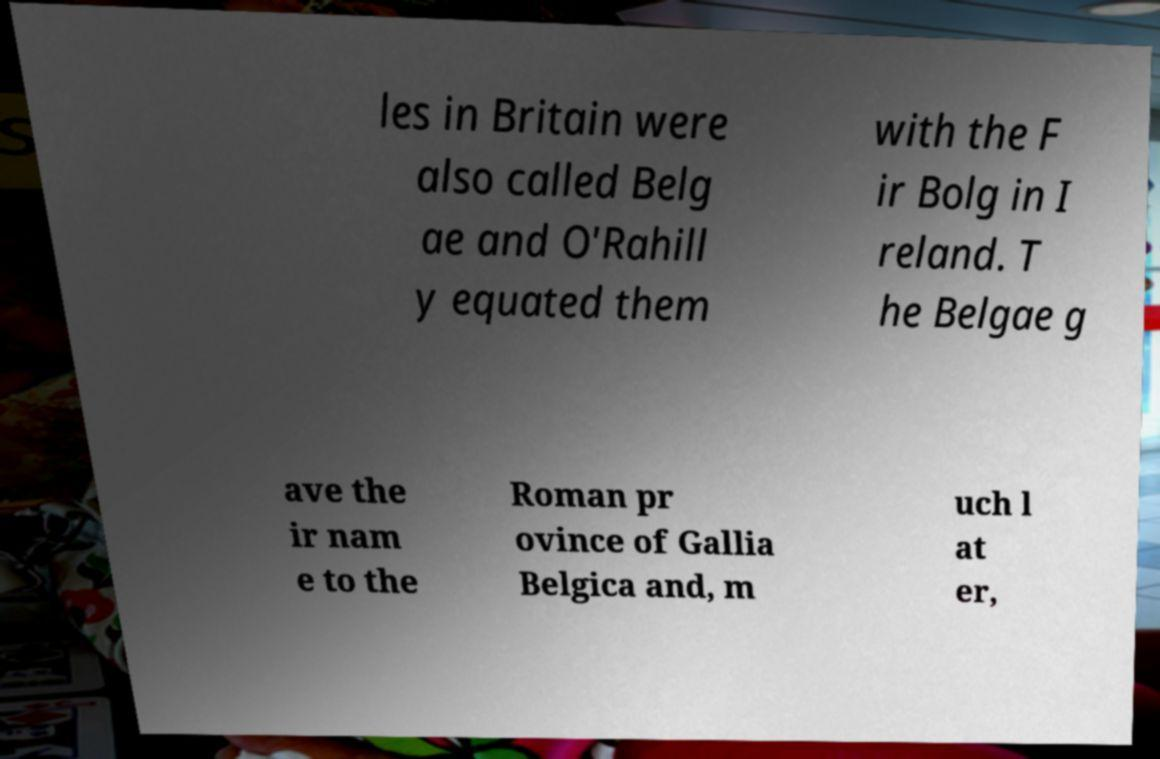Could you extract and type out the text from this image? les in Britain were also called Belg ae and O'Rahill y equated them with the F ir Bolg in I reland. T he Belgae g ave the ir nam e to the Roman pr ovince of Gallia Belgica and, m uch l at er, 